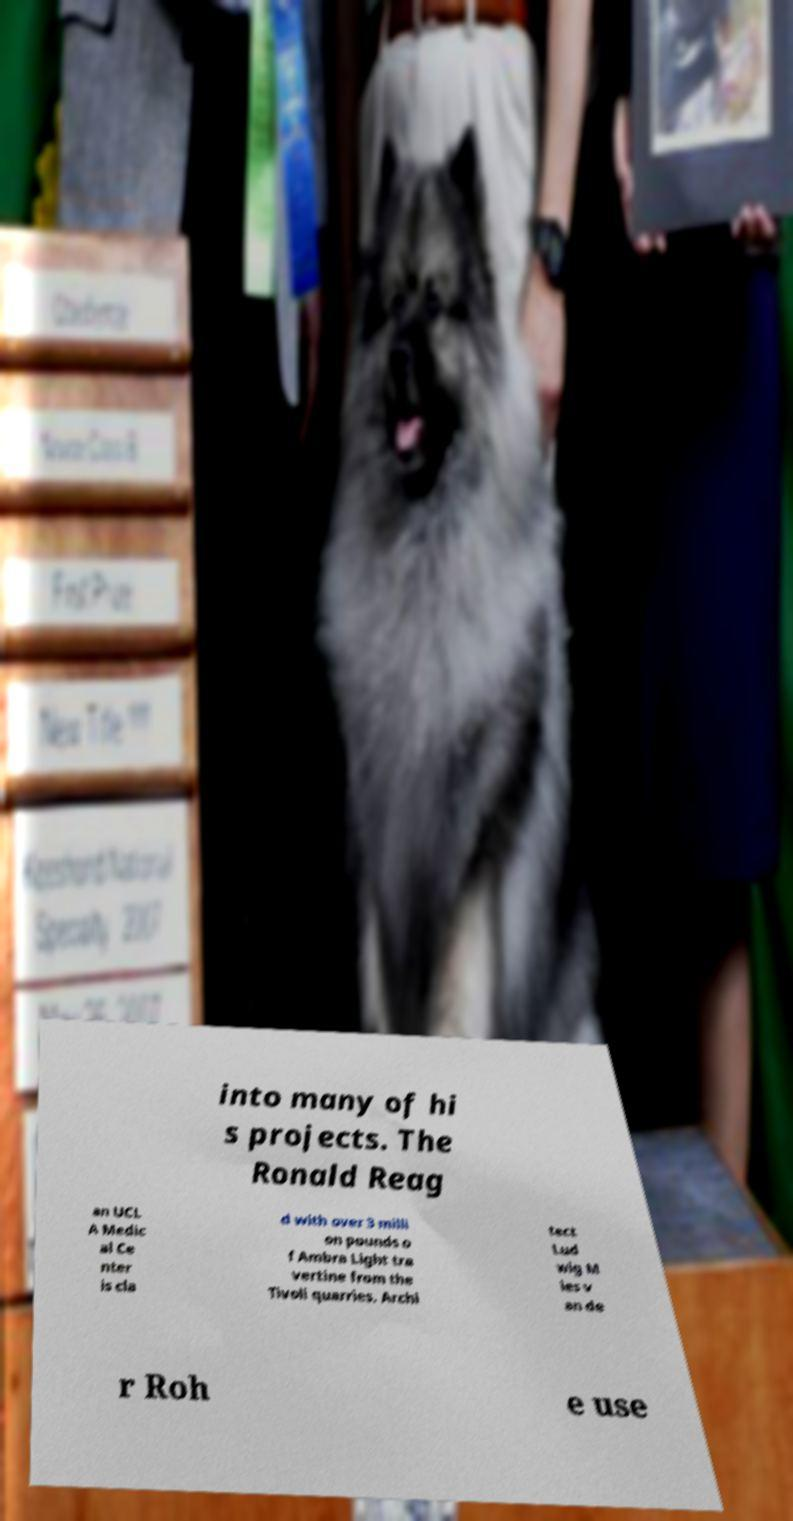Can you accurately transcribe the text from the provided image for me? into many of hi s projects. The Ronald Reag an UCL A Medic al Ce nter is cla d with over 3 milli on pounds o f Ambra Light tra vertine from the Tivoli quarries. Archi tect Lud wig M ies v an de r Roh e use 